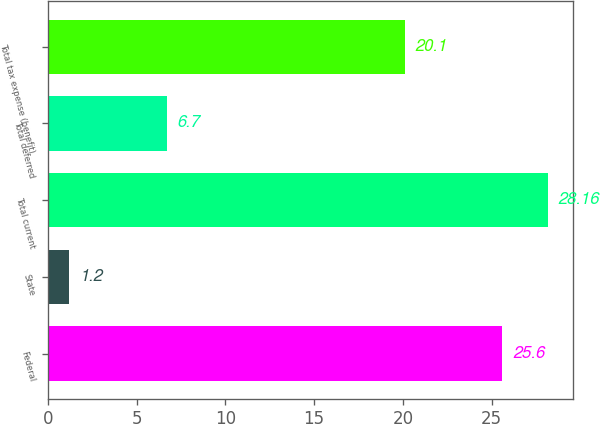Convert chart to OTSL. <chart><loc_0><loc_0><loc_500><loc_500><bar_chart><fcel>Federal<fcel>State<fcel>Total current<fcel>Total deferred<fcel>Total tax expense (benefit)<nl><fcel>25.6<fcel>1.2<fcel>28.16<fcel>6.7<fcel>20.1<nl></chart> 